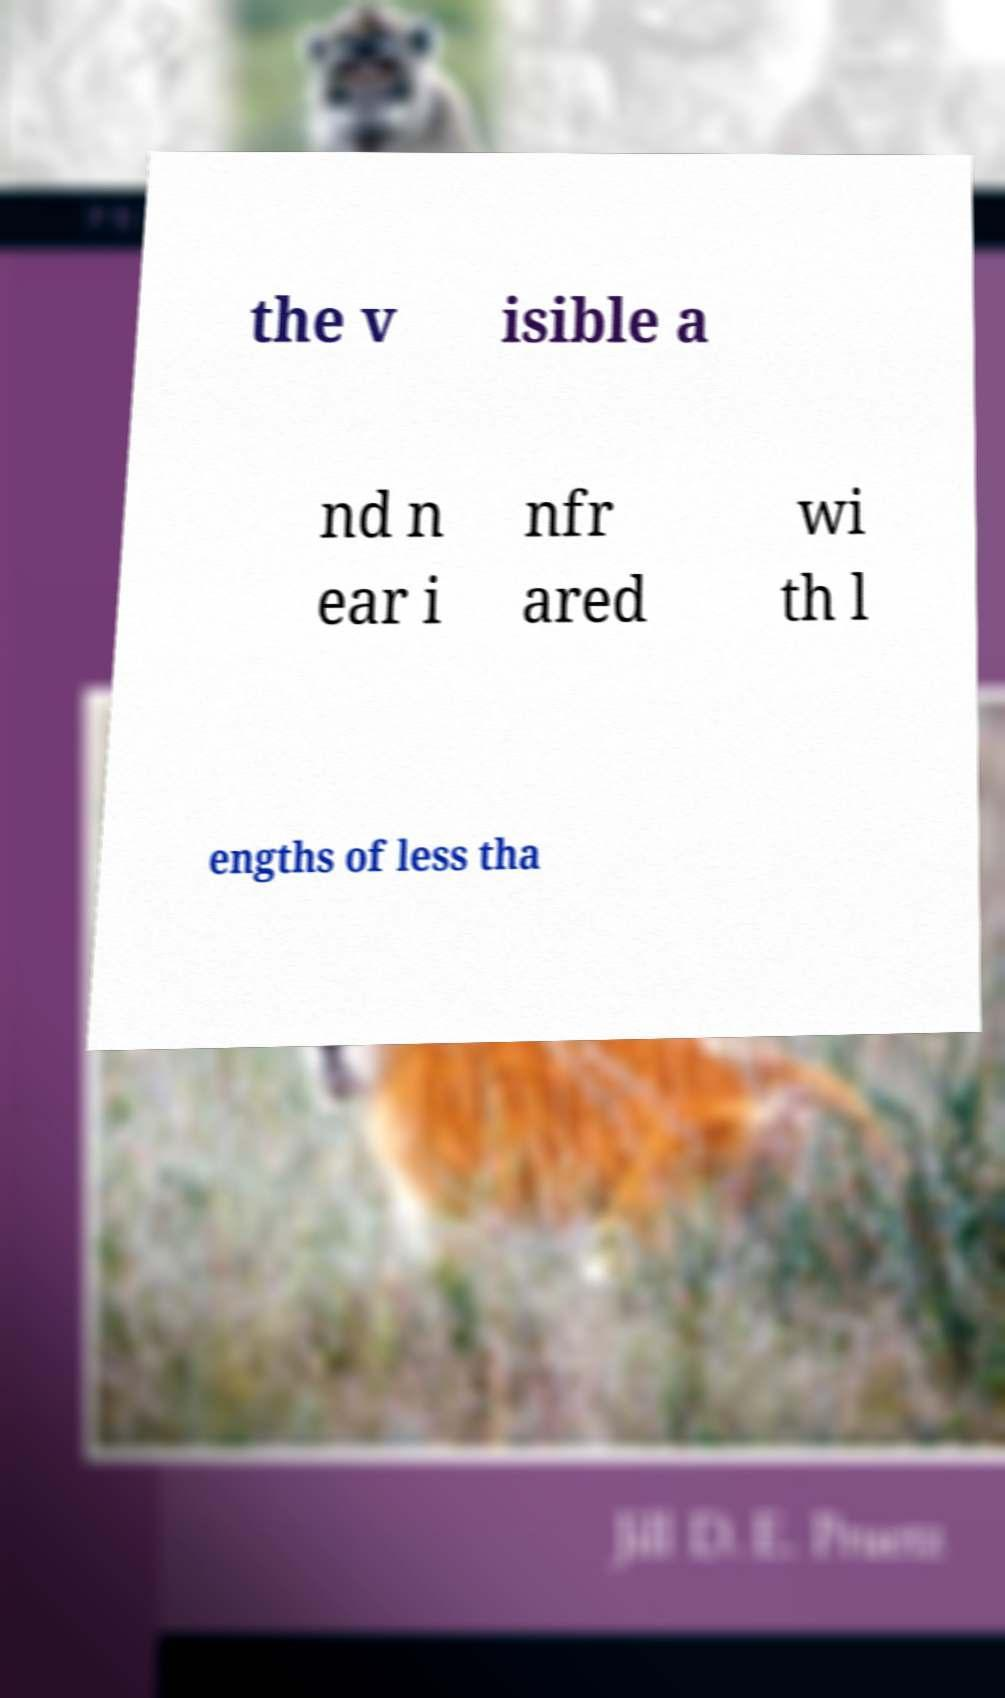What messages or text are displayed in this image? I need them in a readable, typed format. the v isible a nd n ear i nfr ared wi th l engths of less tha 